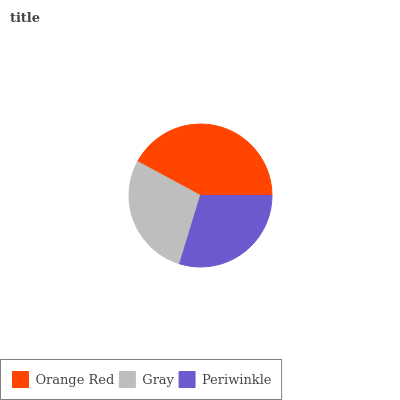Is Gray the minimum?
Answer yes or no. Yes. Is Orange Red the maximum?
Answer yes or no. Yes. Is Periwinkle the minimum?
Answer yes or no. No. Is Periwinkle the maximum?
Answer yes or no. No. Is Periwinkle greater than Gray?
Answer yes or no. Yes. Is Gray less than Periwinkle?
Answer yes or no. Yes. Is Gray greater than Periwinkle?
Answer yes or no. No. Is Periwinkle less than Gray?
Answer yes or no. No. Is Periwinkle the high median?
Answer yes or no. Yes. Is Periwinkle the low median?
Answer yes or no. Yes. Is Gray the high median?
Answer yes or no. No. Is Orange Red the low median?
Answer yes or no. No. 